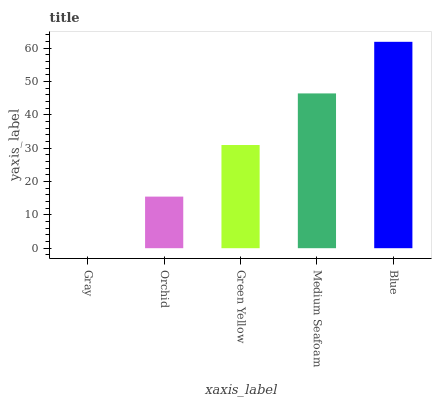Is Gray the minimum?
Answer yes or no. Yes. Is Blue the maximum?
Answer yes or no. Yes. Is Orchid the minimum?
Answer yes or no. No. Is Orchid the maximum?
Answer yes or no. No. Is Orchid greater than Gray?
Answer yes or no. Yes. Is Gray less than Orchid?
Answer yes or no. Yes. Is Gray greater than Orchid?
Answer yes or no. No. Is Orchid less than Gray?
Answer yes or no. No. Is Green Yellow the high median?
Answer yes or no. Yes. Is Green Yellow the low median?
Answer yes or no. Yes. Is Orchid the high median?
Answer yes or no. No. Is Gray the low median?
Answer yes or no. No. 